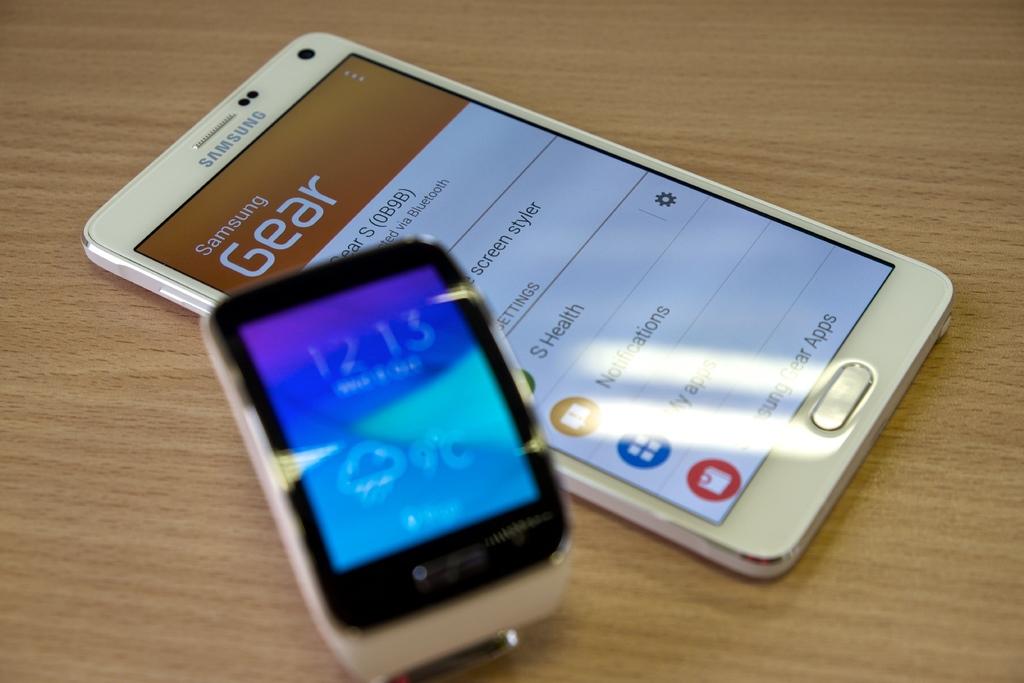What is the brand of the white phone?
Your response must be concise. Samsung. Whats the name on the phone?
Offer a terse response. Samsung. 